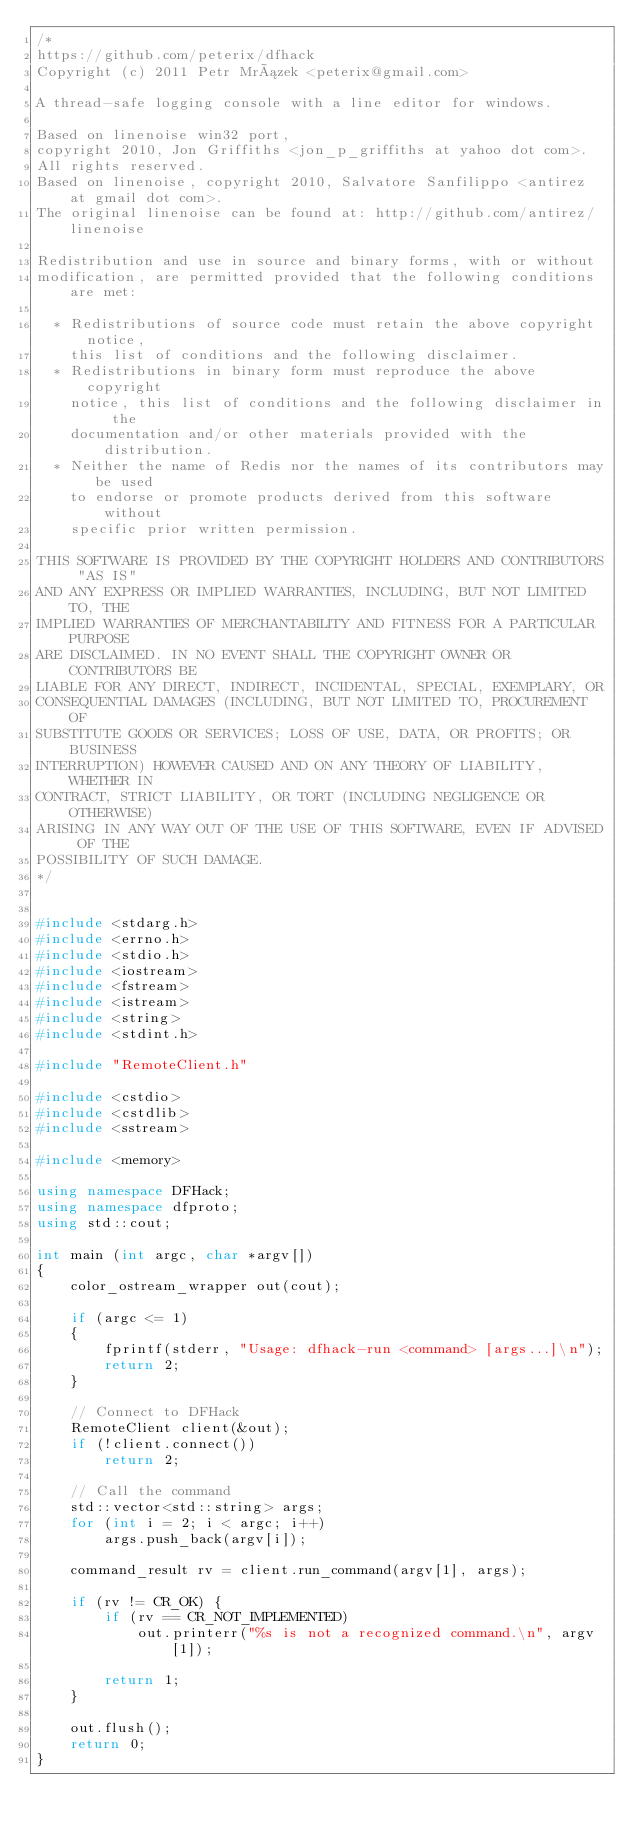<code> <loc_0><loc_0><loc_500><loc_500><_C++_>/*
https://github.com/peterix/dfhack
Copyright (c) 2011 Petr Mrázek <peterix@gmail.com>

A thread-safe logging console with a line editor for windows.

Based on linenoise win32 port,
copyright 2010, Jon Griffiths <jon_p_griffiths at yahoo dot com>.
All rights reserved.
Based on linenoise, copyright 2010, Salvatore Sanfilippo <antirez at gmail dot com>.
The original linenoise can be found at: http://github.com/antirez/linenoise

Redistribution and use in source and binary forms, with or without
modification, are permitted provided that the following conditions are met:

  * Redistributions of source code must retain the above copyright notice,
    this list of conditions and the following disclaimer.
  * Redistributions in binary form must reproduce the above copyright
    notice, this list of conditions and the following disclaimer in the
    documentation and/or other materials provided with the distribution.
  * Neither the name of Redis nor the names of its contributors may be used
    to endorse or promote products derived from this software without
    specific prior written permission.

THIS SOFTWARE IS PROVIDED BY THE COPYRIGHT HOLDERS AND CONTRIBUTORS "AS IS"
AND ANY EXPRESS OR IMPLIED WARRANTIES, INCLUDING, BUT NOT LIMITED TO, THE
IMPLIED WARRANTIES OF MERCHANTABILITY AND FITNESS FOR A PARTICULAR PURPOSE
ARE DISCLAIMED. IN NO EVENT SHALL THE COPYRIGHT OWNER OR CONTRIBUTORS BE
LIABLE FOR ANY DIRECT, INDIRECT, INCIDENTAL, SPECIAL, EXEMPLARY, OR
CONSEQUENTIAL DAMAGES (INCLUDING, BUT NOT LIMITED TO, PROCUREMENT OF
SUBSTITUTE GOODS OR SERVICES; LOSS OF USE, DATA, OR PROFITS; OR BUSINESS
INTERRUPTION) HOWEVER CAUSED AND ON ANY THEORY OF LIABILITY, WHETHER IN
CONTRACT, STRICT LIABILITY, OR TORT (INCLUDING NEGLIGENCE OR OTHERWISE)
ARISING IN ANY WAY OUT OF THE USE OF THIS SOFTWARE, EVEN IF ADVISED OF THE
POSSIBILITY OF SUCH DAMAGE.
*/


#include <stdarg.h>
#include <errno.h>
#include <stdio.h>
#include <iostream>
#include <fstream>
#include <istream>
#include <string>
#include <stdint.h>

#include "RemoteClient.h"

#include <cstdio>
#include <cstdlib>
#include <sstream>

#include <memory>

using namespace DFHack;
using namespace dfproto;
using std::cout;

int main (int argc, char *argv[])
{
    color_ostream_wrapper out(cout);

    if (argc <= 1)
    {
        fprintf(stderr, "Usage: dfhack-run <command> [args...]\n");
        return 2;
    }

    // Connect to DFHack
    RemoteClient client(&out);
    if (!client.connect())
        return 2;

    // Call the command
    std::vector<std::string> args;
    for (int i = 2; i < argc; i++)
        args.push_back(argv[i]);

    command_result rv = client.run_command(argv[1], args);

    if (rv != CR_OK) {
        if (rv == CR_NOT_IMPLEMENTED)
            out.printerr("%s is not a recognized command.\n", argv[1]);

        return 1;
    }

    out.flush();
    return 0;
}
</code> 